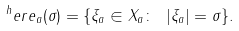<formula> <loc_0><loc_0><loc_500><loc_500>^ { h } e r e _ { a } ( \sigma ) = \{ \xi _ { a } \in X _ { a } \colon \ | \xi _ { a } | = \sigma \} .</formula> 